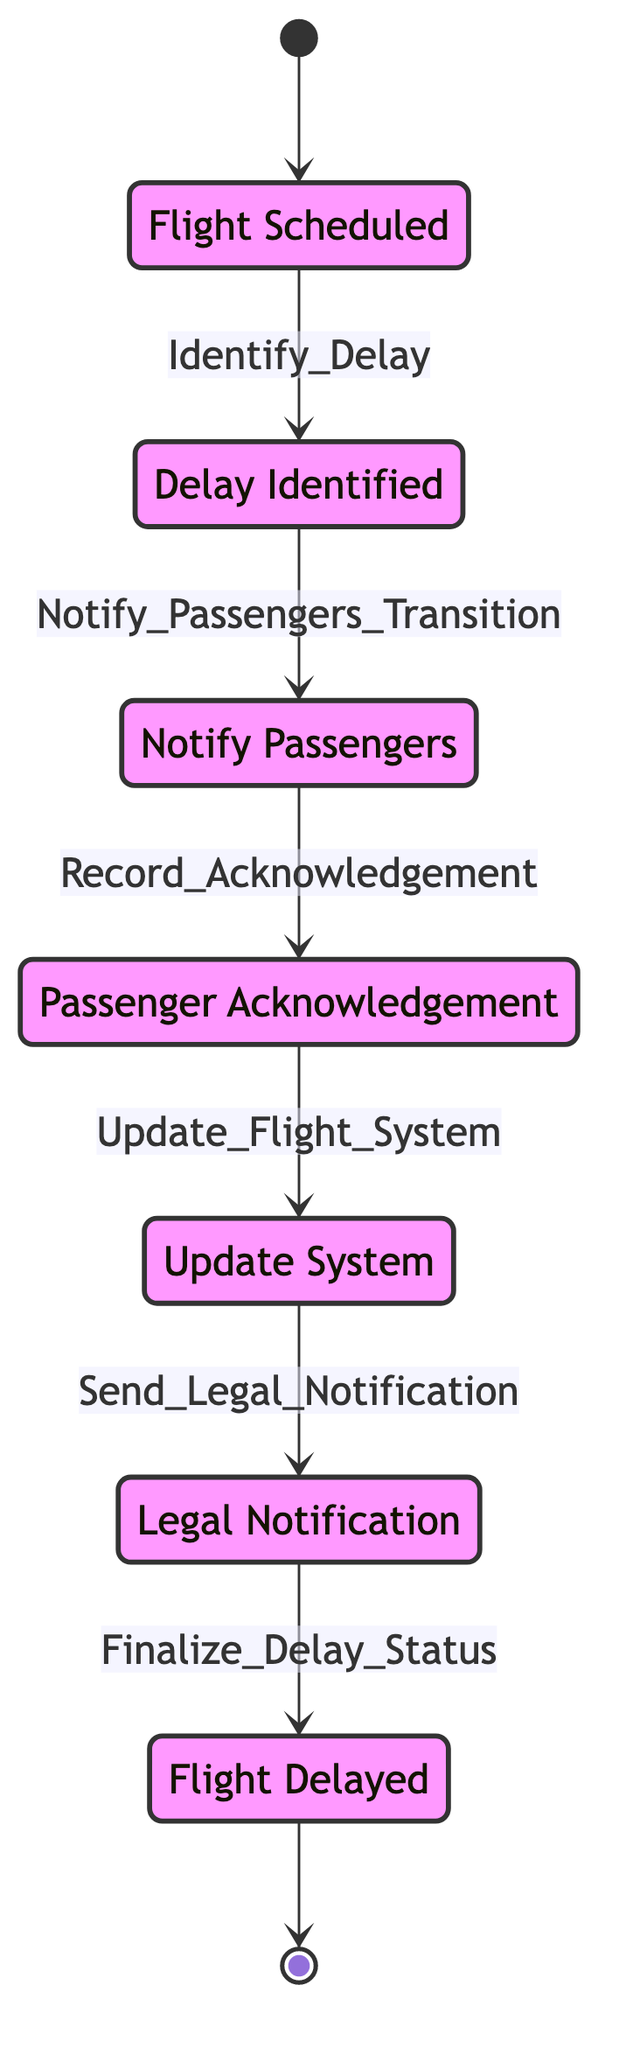What's the initial state in the diagram? The diagram's initial state is represented as the node that points to "Flight_Scheduled." This indicates that the process begins with flights being scheduled.
Answer: Flight Scheduled How many states are there in total? By counting all the distinct states depicted in the diagram, we find that there are a total of seven states.
Answer: Seven Which state comes after "Notify_Passengers"? The diagram shows that after the "Notify_Passengers" state, the next state is "Passenger_Acknowledgement," following the transition labeled "Record_Acknowledgement."
Answer: Passenger Acknowledgement What transition allows movement from "Update_System" to "Legal_Notification"? The transition that facilitates the move from "Update_System" to "Legal_Notification" is labeled "Send_Legal_Notification."
Answer: Send Legal Notification Which state is the final state in the process? The final state, as indicated by the endpoint of the diagram, is "Flight_Delayed," showing that the flight status is ultimately delayed at the end of this process.
Answer: Flight Delayed How many transitions are there in total? Counting the connections between the states, we find that there are six transitions depicted in the diagram.
Answer: Six What is the relationship between "Delay_Identified" and "Notify_Passengers"? The diagram illustrates that the "Delay_Identified" state transitions to "Notify_Passengers" through the transition named "Notify_Passengers_Transition," indicating that the process moves from identifying a delay to notifying passengers about it.
Answer: Notify Passengers Transition What state is reached after sending legal notifications? After the state "Legal_Notification," the process transitions to the state "Flight_Delayed," indicating that the final outcome follows the legal notifications being sent.
Answer: Flight Delayed 